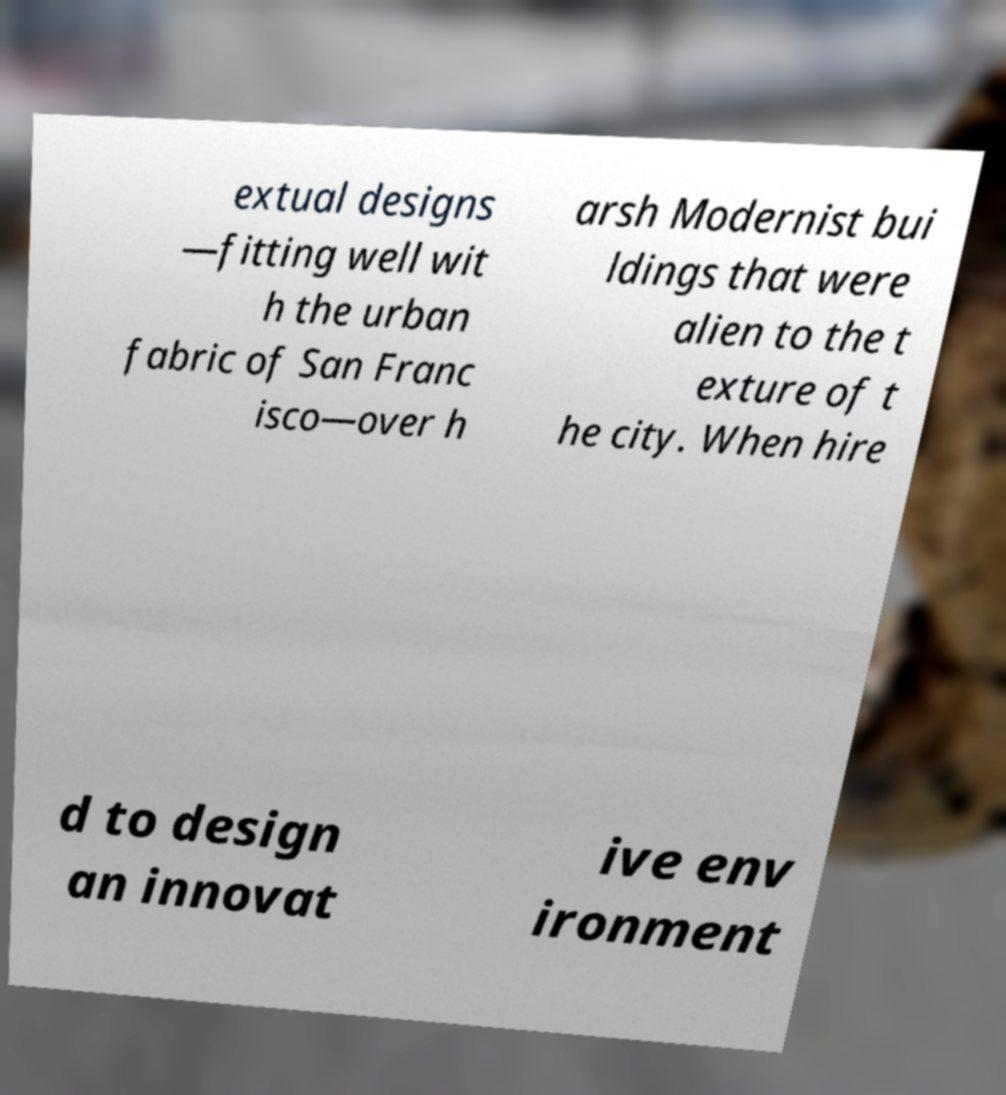Can you read and provide the text displayed in the image?This photo seems to have some interesting text. Can you extract and type it out for me? extual designs —fitting well wit h the urban fabric of San Franc isco—over h arsh Modernist bui ldings that were alien to the t exture of t he city. When hire d to design an innovat ive env ironment 